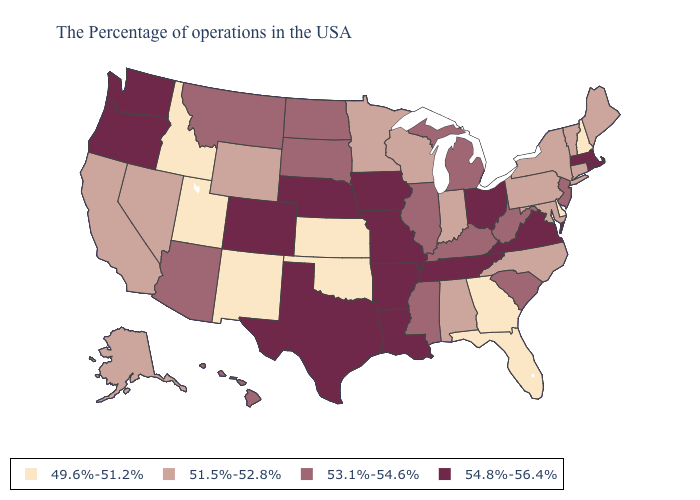What is the value of Alaska?
Quick response, please. 51.5%-52.8%. Does Washington have the lowest value in the West?
Answer briefly. No. Does Ohio have the highest value in the USA?
Answer briefly. Yes. Does Georgia have the lowest value in the USA?
Give a very brief answer. Yes. Name the states that have a value in the range 53.1%-54.6%?
Answer briefly. New Jersey, South Carolina, West Virginia, Michigan, Kentucky, Illinois, Mississippi, South Dakota, North Dakota, Montana, Arizona, Hawaii. Does New York have a lower value than Wisconsin?
Keep it brief. No. Does Missouri have a higher value than Mississippi?
Concise answer only. Yes. How many symbols are there in the legend?
Concise answer only. 4. Among the states that border Iowa , does Illinois have the highest value?
Answer briefly. No. Does the map have missing data?
Keep it brief. No. Name the states that have a value in the range 49.6%-51.2%?
Quick response, please. New Hampshire, Delaware, Florida, Georgia, Kansas, Oklahoma, New Mexico, Utah, Idaho. What is the value of Missouri?
Write a very short answer. 54.8%-56.4%. How many symbols are there in the legend?
Concise answer only. 4. Does Virginia have the highest value in the USA?
Write a very short answer. Yes. 